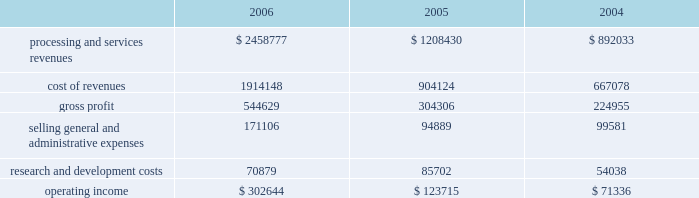Higher average borrowings .
Additionally , the recapitalization that occurred late in the first quarter of 2005 resulted in a full year of interest in 2006 as compared to approximately ten months in 2005 .
The increase in interest expense in 2005 as compared to 2004 also resulted from the recapitalization in 2005 .
Income tax expense income tax expense totaled $ 150.2 million , $ 116.1 million and $ 118.3 million for 2006 , 2005 and 2004 , respectively .
This resulted in an effective tax rate of 37.2% ( 37.2 % ) , 37.2% ( 37.2 % ) and 37.6% ( 37.6 % ) for 2006 , 2005 and 2004 , respectively .
Net earnings net earnings totaled $ 259.1 million , $ 196.6 and $ 189.4 million for 2006 , 2005 and 2004 , respectively , or $ 1.37 , $ 1.53 and $ 1.48 per diluted share , respectively .
Segment results of operations transaction processing services ( in thousands ) .
Revenues for the transaction processing services segment are derived from three main revenue channels ; enterprise solutions , integrated financial solutions and international .
Revenues from transaction processing services totaled $ 2458.8 million , $ 1208.4 and $ 892.0 million for 2006 , 2005 and 2004 , respectively .
The overall segment increase of $ 1250.4 million during 2006 , as compared to 2005 was primarily attributable to the certegy merger which contributed $ 1067.2 million to the overall increase .
The majority of the remaining 2006 growth is attributable to organic growth within the historically owned integrated financial solutions and international revenue channels , with international including $ 31.9 million related to the newly formed business process outsourcing operation in brazil .
The overall segment increase of $ 316.4 in 2005 as compared to 2004 results from the inclusion of a full year of results for the 2004 acquisitions of aurum , sanchez , kordoba , and intercept , which contributed $ 301.1 million of the increase .
Cost of revenues for the transaction processing services segment totaled $ 1914.1 million , $ 904.1 million and $ 667.1 million for 2006 , 2005 and 2004 , respectively .
The overall segment increase of $ 1010.0 million during 2006 as compared to 2005 was primarily attributable to the certegy merger which contributed $ 848.2 million to the increase .
Gross profit as a percentage of revenues ( 201cgross margin 201d ) was 22.2% ( 22.2 % ) , 25.2% ( 25.2 % ) and 25.2% ( 25.2 % ) for 2006 , 2005 and 2004 , respectively .
The decrease in gross profit in 2006 as compared to 2005 is primarily due to the february 1 , 2006 certegy merger , which businesses typically have lower margins than those of the historically owned fis businesses .
Incremental intangible asset amortization relating to the certegy merger also contributed to the decrease in gross margin .
Included in cost of revenues was depreciation and amortization of $ 272.4 million , $ 139.8 million , and $ 94.6 million for 2006 , 2005 and 2004 , respectively .
Selling , general and administrative expenses totaled $ 171.1 million , $ 94.9 million and $ 99.6 million for 2006 , 2005 and 2004 , respectively .
The increase in 2006 compared to 2005 is primarily attributable to the certegy merger which contributed $ 73.7 million to the overall increase of $ 76.2 million .
The decrease of $ 4.7 million in 2005 as compared to 2004 is primarily attributable to the effect of acquisition related costs in 2004 .
Included in selling , general and administrative expenses was depreciation and amortization of $ 11.0 million , $ 9.1 million and $ 2.3 million for 2006 , 2005 and 2004 , respectively. .
What was the percentage change in operating income from 2005 to 2006? 
Computations: ((302644 - 123715) / 123715)
Answer: 1.4463. 